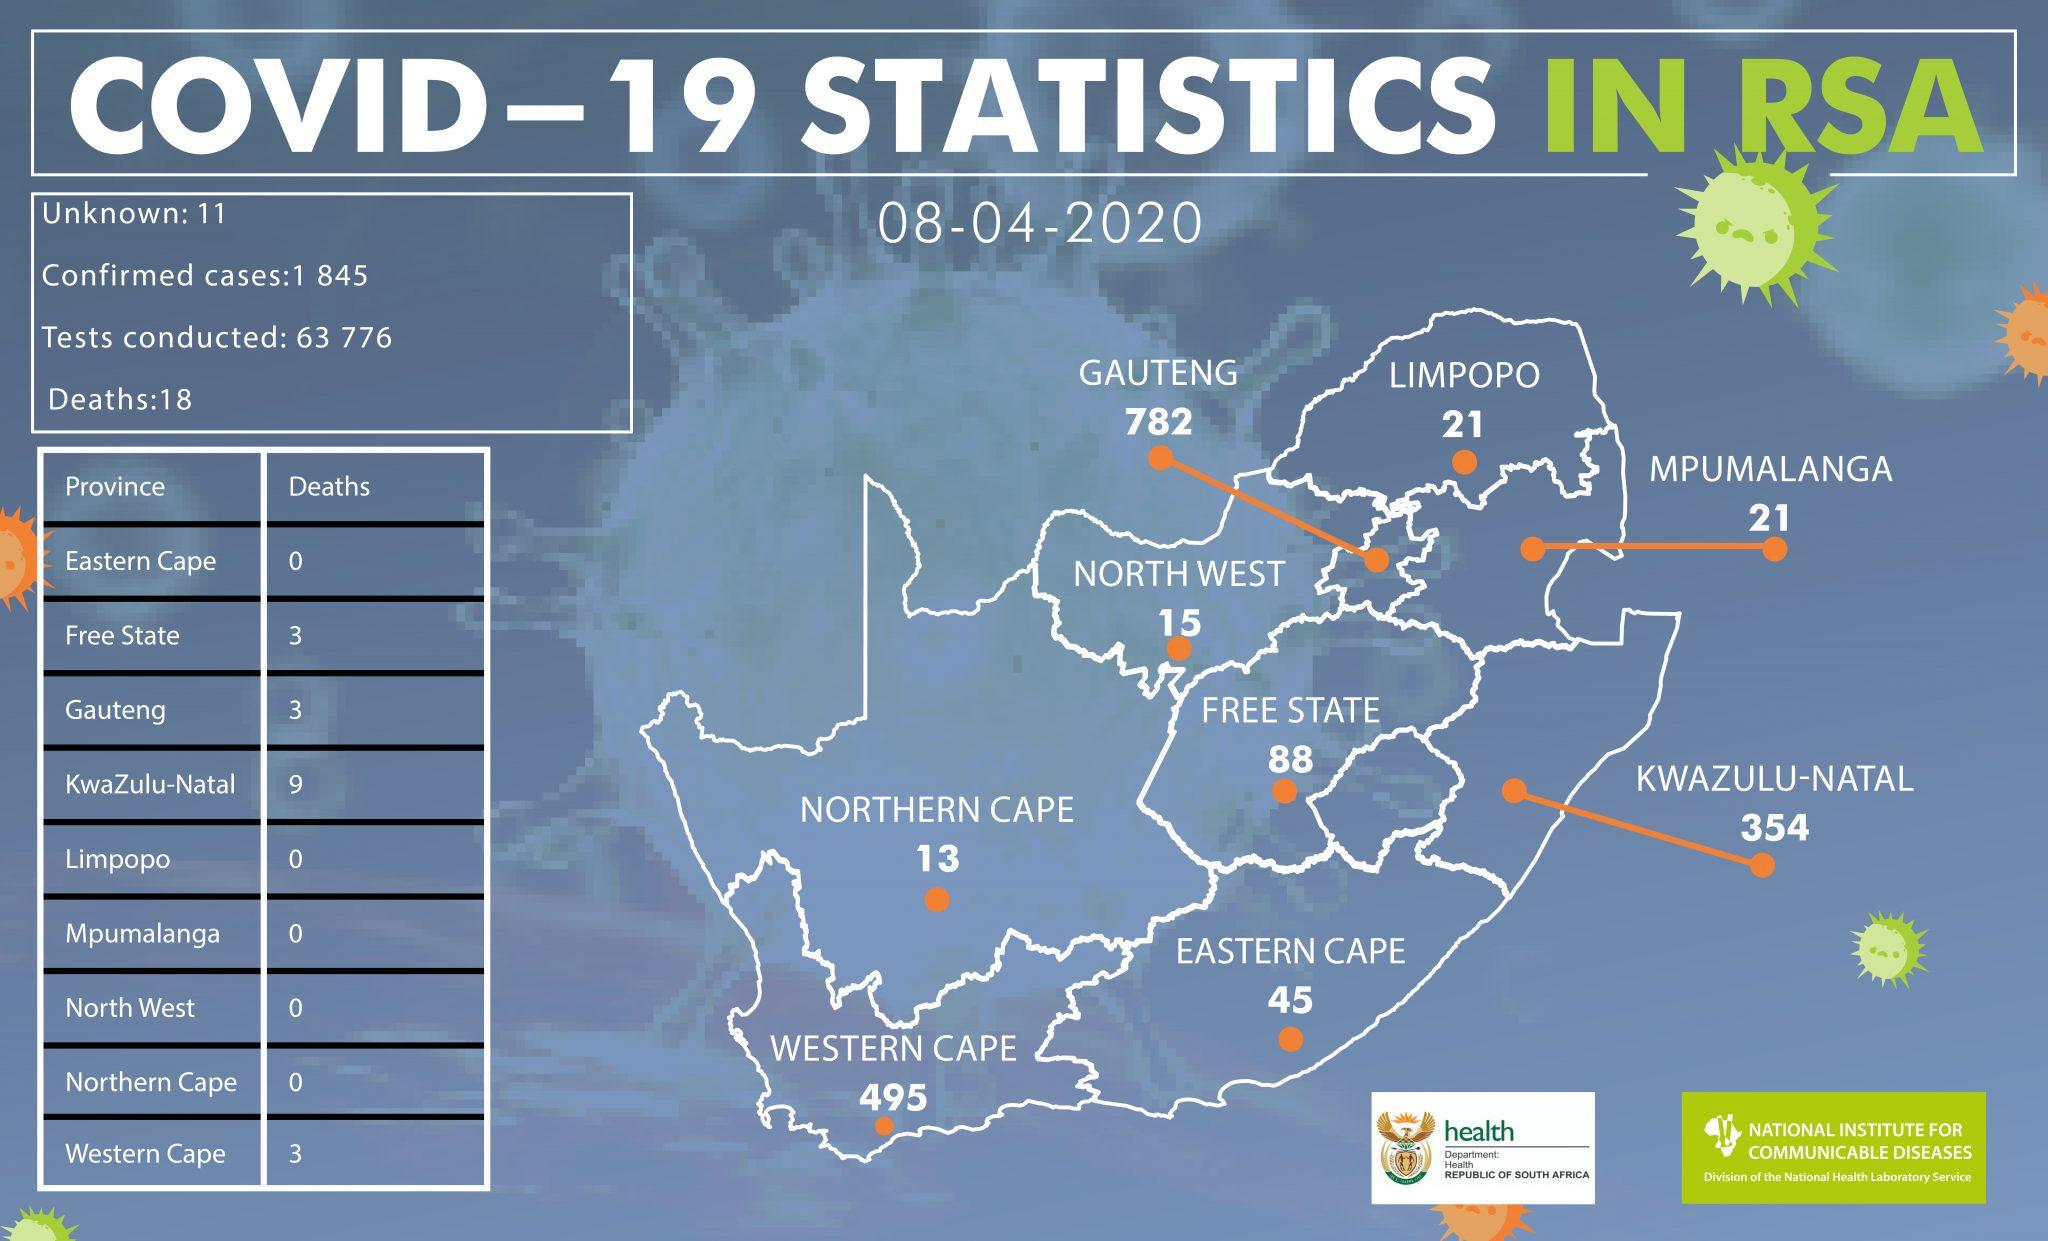Specify some key components in this picture. Two provinces, Limpopo and Mpumalanga, have confirmed cases of 21. During the outbreak, the provinces of Free State, Gauteng, and Western Cape had a combined death count of three individuals. Out of the total number of deaths, KwaZulu-Natal province recorded the highest proportion of 50%. Western Cape has the second highest number of COVID-19 cases. In the Eastern Cape, Northern Cape, and Western Cape, a total of 3 deaths were reported. 